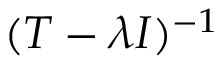Convert formula to latex. <formula><loc_0><loc_0><loc_500><loc_500>( T - \lambda I ) ^ { - 1 }</formula> 